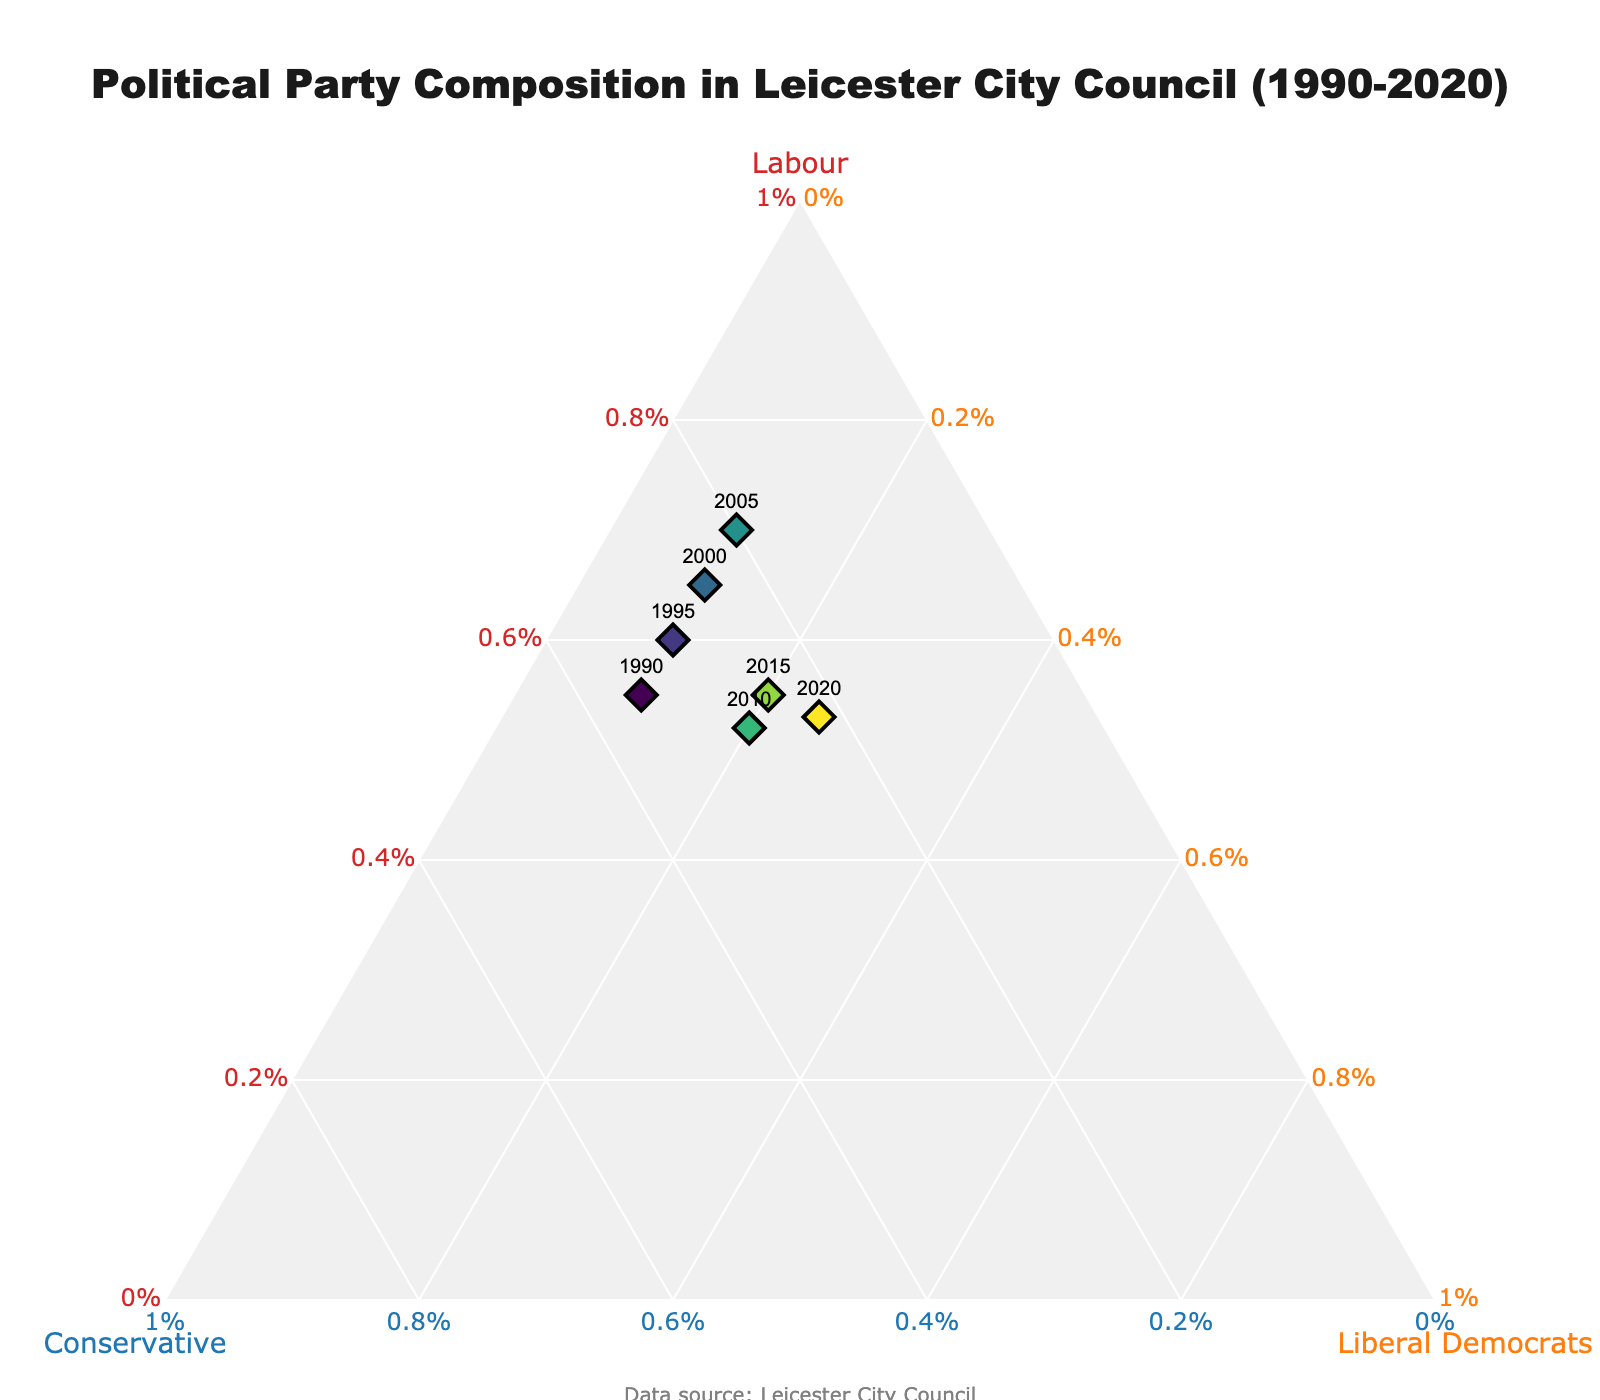What's the proportion of Labour votes in 2000? Locate 2000 in the graph and refer to the 'Labour' axis, which shows 65%.
Answer: 65% What trend do you observe for the Conservative party over three decades? Follow the points for Conservative over the years. It starts at 35% in 1990, decreases to 20% in 2005, increases slightly to 28% in 2010, and then declines again to 22% in 2020.
Answer: Decreasing overall Which year has the highest proportion of Liberal Democrats? Identify the point farthest along the 'Liberal Democrats' axis, which is 2020 at 25%.
Answer: 2020 How does the proportion of Labour votes change from 1990 to 2020? Refer to the Labour axis for 1990 and 2020, noting that the proportion decreases from 55% in 1990 to 53% in 2020.
Answer: Decreases slightly Is there any year where Labour and Liberal Democrats together have 80% or more combined votes? Check each year's Labour and Liberal Democrats percentages: Only in 2005 (Labour 70% + Liberal Democrats 10% = 80%).
Answer: Yes, in 2005 What is the sum of Labour and Conservative proportions in 2015? Add the proportions for Labour (55%) and Conservative (25%) from 2015. The total is 55% + 25% = 80%.
Answer: 80% Which year has the most balanced distribution among all three parties? The most balanced year will have the most even proportions for Labour, Conservative, and Liberal Democrats. Check visually and 2010 (Labour 52%, Conservative 28%, Liberal Democrats 20%) is close to balanced.
Answer: 2010 How many data points indicate a stable proportion for Liberal Democrats? Look for years where Liberal Democrats' proportion remains constant: It's 10% for years 1990 to 2005 and increases afterward.
Answer: 4 years Which year shows the lowest proportion for the Conservative party? The lowest proportion for Conservative is 20%, observed in 2005.
Answer: 2005 What was the difference in the proportion of Labour votes between 1995 and 2015? Subtract Labour's proportion in 1995 (60%) from 2015 (55%). The answer is 60% - 55% = 5%.
Answer: 5% 